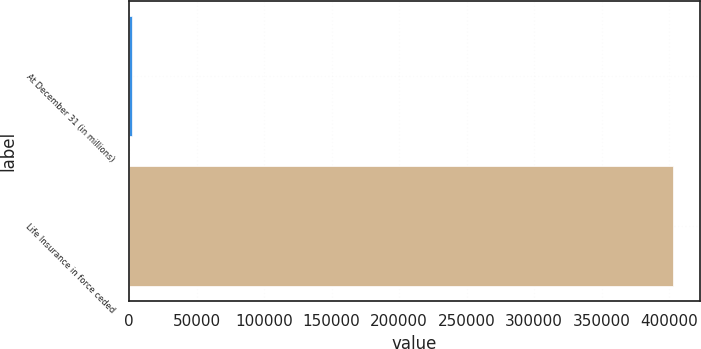Convert chart. <chart><loc_0><loc_0><loc_500><loc_500><bar_chart><fcel>At December 31 (in millions)<fcel>Life Insurance in force ceded<nl><fcel>2007<fcel>402654<nl></chart> 